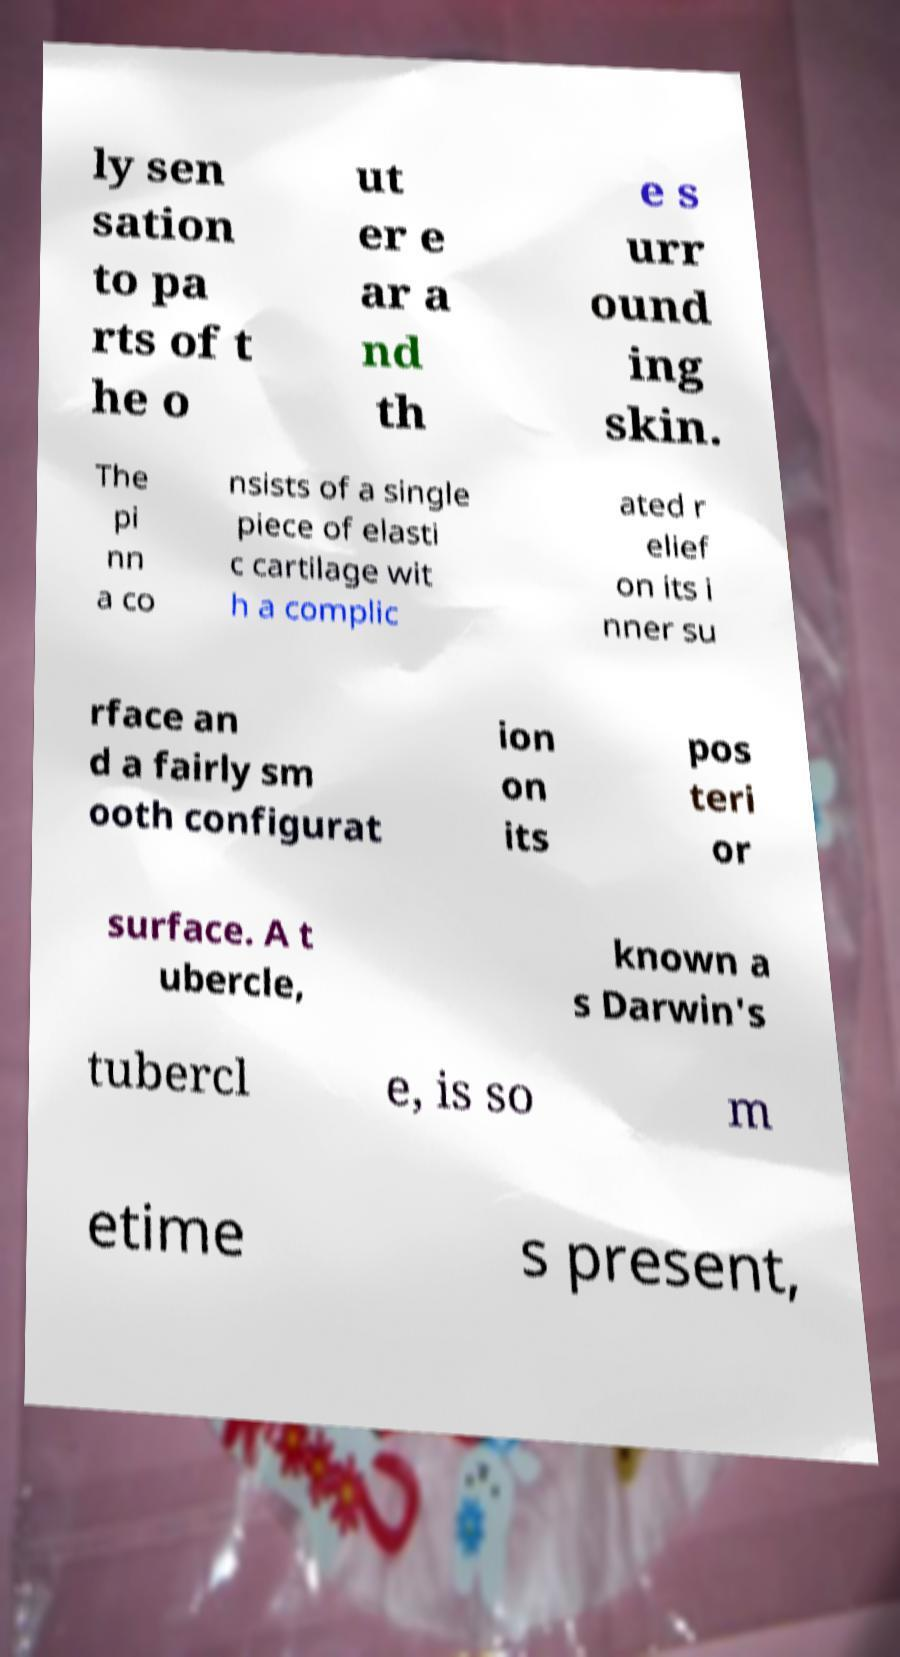I need the written content from this picture converted into text. Can you do that? ly sen sation to pa rts of t he o ut er e ar a nd th e s urr ound ing skin. The pi nn a co nsists of a single piece of elasti c cartilage wit h a complic ated r elief on its i nner su rface an d a fairly sm ooth configurat ion on its pos teri or surface. A t ubercle, known a s Darwin's tubercl e, is so m etime s present, 